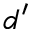<formula> <loc_0><loc_0><loc_500><loc_500>d ^ { \prime }</formula> 